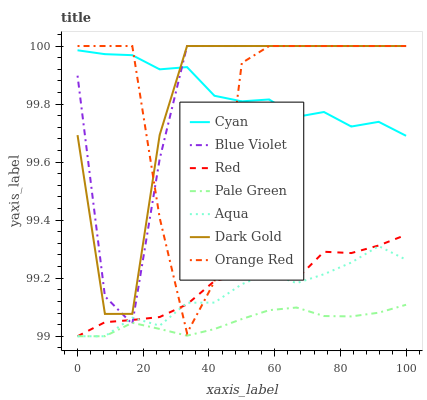Does Pale Green have the minimum area under the curve?
Answer yes or no. Yes. Does Cyan have the maximum area under the curve?
Answer yes or no. Yes. Does Aqua have the minimum area under the curve?
Answer yes or no. No. Does Aqua have the maximum area under the curve?
Answer yes or no. No. Is Pale Green the smoothest?
Answer yes or no. Yes. Is Orange Red the roughest?
Answer yes or no. Yes. Is Aqua the smoothest?
Answer yes or no. No. Is Aqua the roughest?
Answer yes or no. No. Does Aqua have the lowest value?
Answer yes or no. Yes. Does Blue Violet have the lowest value?
Answer yes or no. No. Does Orange Red have the highest value?
Answer yes or no. Yes. Does Aqua have the highest value?
Answer yes or no. No. Is Pale Green less than Orange Red?
Answer yes or no. Yes. Is Dark Gold greater than Aqua?
Answer yes or no. Yes. Does Orange Red intersect Cyan?
Answer yes or no. Yes. Is Orange Red less than Cyan?
Answer yes or no. No. Is Orange Red greater than Cyan?
Answer yes or no. No. Does Pale Green intersect Orange Red?
Answer yes or no. No. 